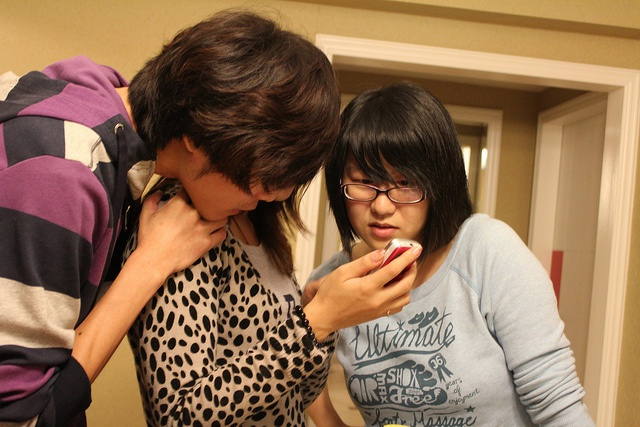Describe the objects in this image and their specific colors. I can see people in tan, black, maroon, and brown tones, people in tan, black, lightgray, darkgray, and gray tones, people in tan, black, and gray tones, and cell phone in tan, maroon, brown, and beige tones in this image. 